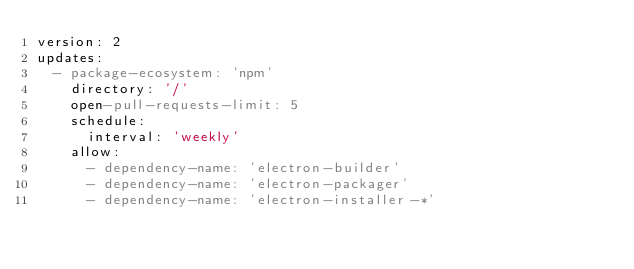Convert code to text. <code><loc_0><loc_0><loc_500><loc_500><_YAML_>version: 2
updates:
  - package-ecosystem: 'npm'
    directory: '/'
    open-pull-requests-limit: 5
    schedule:
      interval: 'weekly'
    allow:
      - dependency-name: 'electron-builder'
      - dependency-name: 'electron-packager'
      - dependency-name: 'electron-installer-*'
</code> 